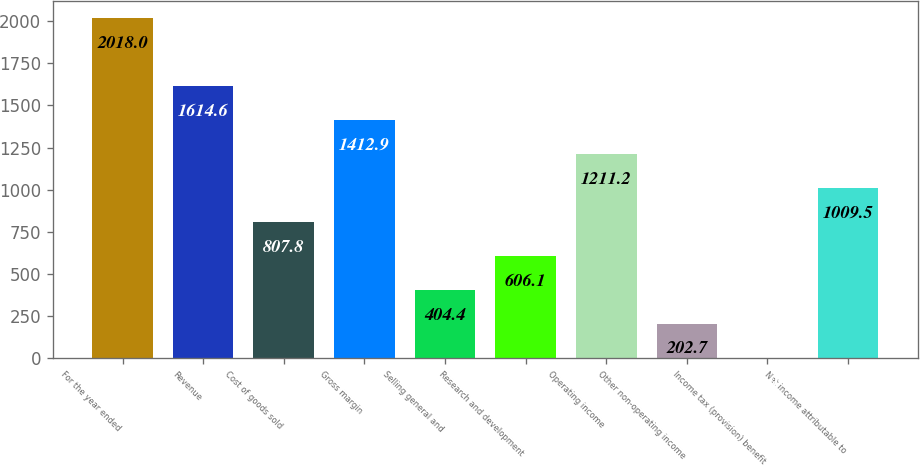<chart> <loc_0><loc_0><loc_500><loc_500><bar_chart><fcel>For the year ended<fcel>Revenue<fcel>Cost of goods sold<fcel>Gross margin<fcel>Selling general and<fcel>Research and development<fcel>Operating income<fcel>Other non-operating income<fcel>Income tax (provision) benefit<fcel>Net income attributable to<nl><fcel>2018<fcel>1614.6<fcel>807.8<fcel>1412.9<fcel>404.4<fcel>606.1<fcel>1211.2<fcel>202.7<fcel>1<fcel>1009.5<nl></chart> 